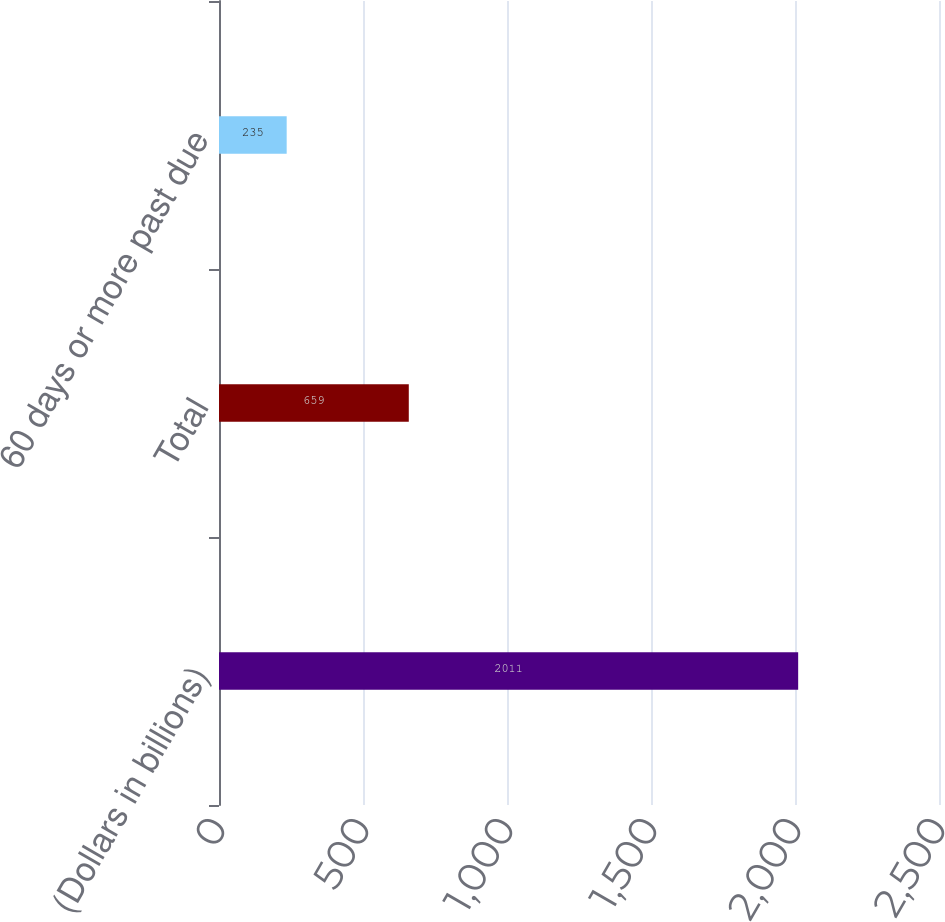<chart> <loc_0><loc_0><loc_500><loc_500><bar_chart><fcel>(Dollars in billions)<fcel>Total<fcel>60 days or more past due<nl><fcel>2011<fcel>659<fcel>235<nl></chart> 